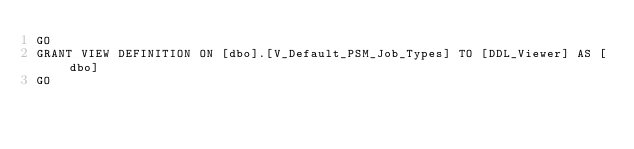<code> <loc_0><loc_0><loc_500><loc_500><_SQL_>GO
GRANT VIEW DEFINITION ON [dbo].[V_Default_PSM_Job_Types] TO [DDL_Viewer] AS [dbo]
GO
</code> 